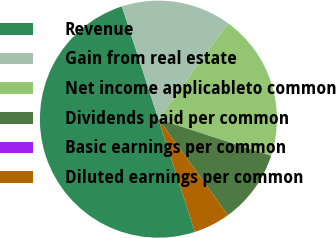<chart> <loc_0><loc_0><loc_500><loc_500><pie_chart><fcel>Revenue<fcel>Gain from real estate<fcel>Net income applicableto common<fcel>Dividends paid per common<fcel>Basic earnings per common<fcel>Diluted earnings per common<nl><fcel>50.0%<fcel>15.0%<fcel>20.0%<fcel>10.0%<fcel>0.0%<fcel>5.0%<nl></chart> 